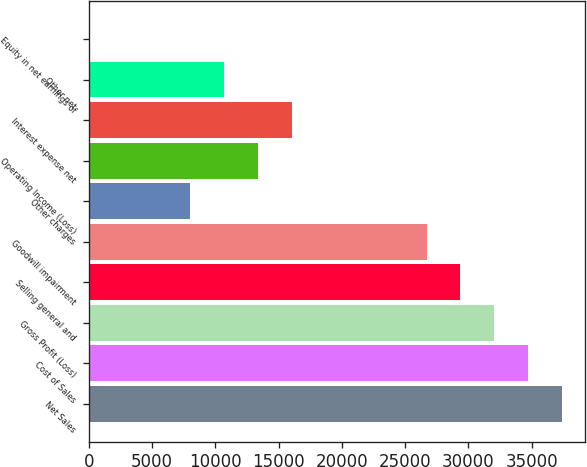Convert chart to OTSL. <chart><loc_0><loc_0><loc_500><loc_500><bar_chart><fcel>Net Sales<fcel>Cost of Sales<fcel>Gross Profit (Loss)<fcel>Selling general and<fcel>Goodwill impairment<fcel>Other charges<fcel>Operating Income (Loss)<fcel>Interest expense net<fcel>Other net<fcel>Equity in net earnings of<nl><fcel>37385.6<fcel>34715.2<fcel>32044.8<fcel>29374.4<fcel>26704<fcel>8011.28<fcel>13352.1<fcel>16022.5<fcel>10681.7<fcel>0.11<nl></chart> 